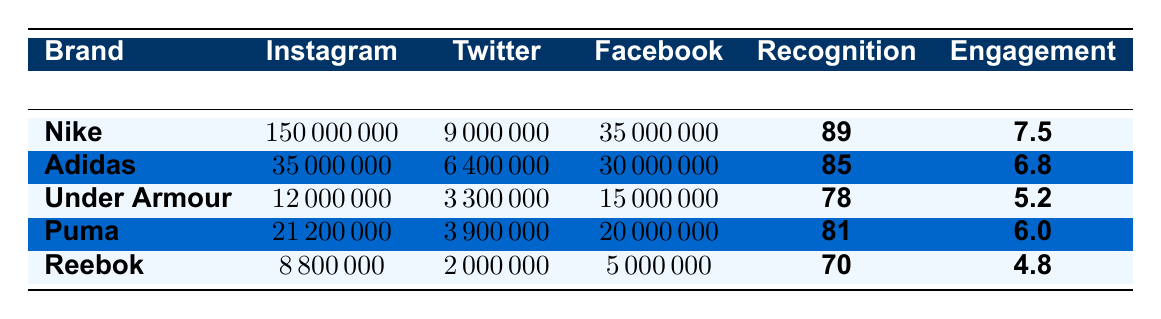What is the brand recognition score for Nike? The brand recognition score for Nike is explicitly listed in the table under the "Recognition" column.
Answer: 89 How many social media followers does Adidas have on Instagram? The number of Instagram followers for Adidas is directly available in the "Instagram" column of the table.
Answer: 35,000,000 Which brand has the highest engagement rate? By comparing the engagement rates listed in the "Engagement" column, Nike has the highest engagement rate at 7.5%.
Answer: Nike What is the total number of social media followers for Under Armour across all platforms? Adding the followers from all platforms for Under Armour: 12,000,000 (Instagram) + 3,300,000 (Twitter) + 15,000,000 (Facebook) equals 30,300,000.
Answer: 30,300,000 Which brand collaborated with Rihanna for their campaign? The brand that collaborated with Rihanna is explicitly stated in the "influencer_collaboration" field under Puma.
Answer: Puma Is the engagement rate for Reebok higher than that for Under Armour? The engagement rate for Reebok is 4.8%, and for Under Armour, it is 5.2%. Since 4.8% < 5.2%, the engagement rate for Reebok is not higher.
Answer: No What is the average brand recognition score for all the brands listed in the table? The average can be calculated by summing the scores: (89 + 85 + 78 + 81 + 70) = 403, and dividing by 5 yields an average of 80.6.
Answer: 80.6 Which brand has the least number of Twitter followers? By examining the Twitter followers listed in the table, Reebok has 2,000,000 followers, which is the least among all brands.
Answer: Reebok How much higher is Nike's recognition score compared to Reebok's? The difference in scores between Nike (89) and Reebok (70) can be found by subtracting: 89 - 70 = 19.
Answer: 19 Which brand has the lowest total number of social media followers combined? Adding the total followers for each brand, Reebok has 8,800,000 (Instagram) + 2,000,000 (Twitter) + 5,000,000 (Facebook) = 15,800,000, making it the brand with the lowest total.
Answer: Reebok 